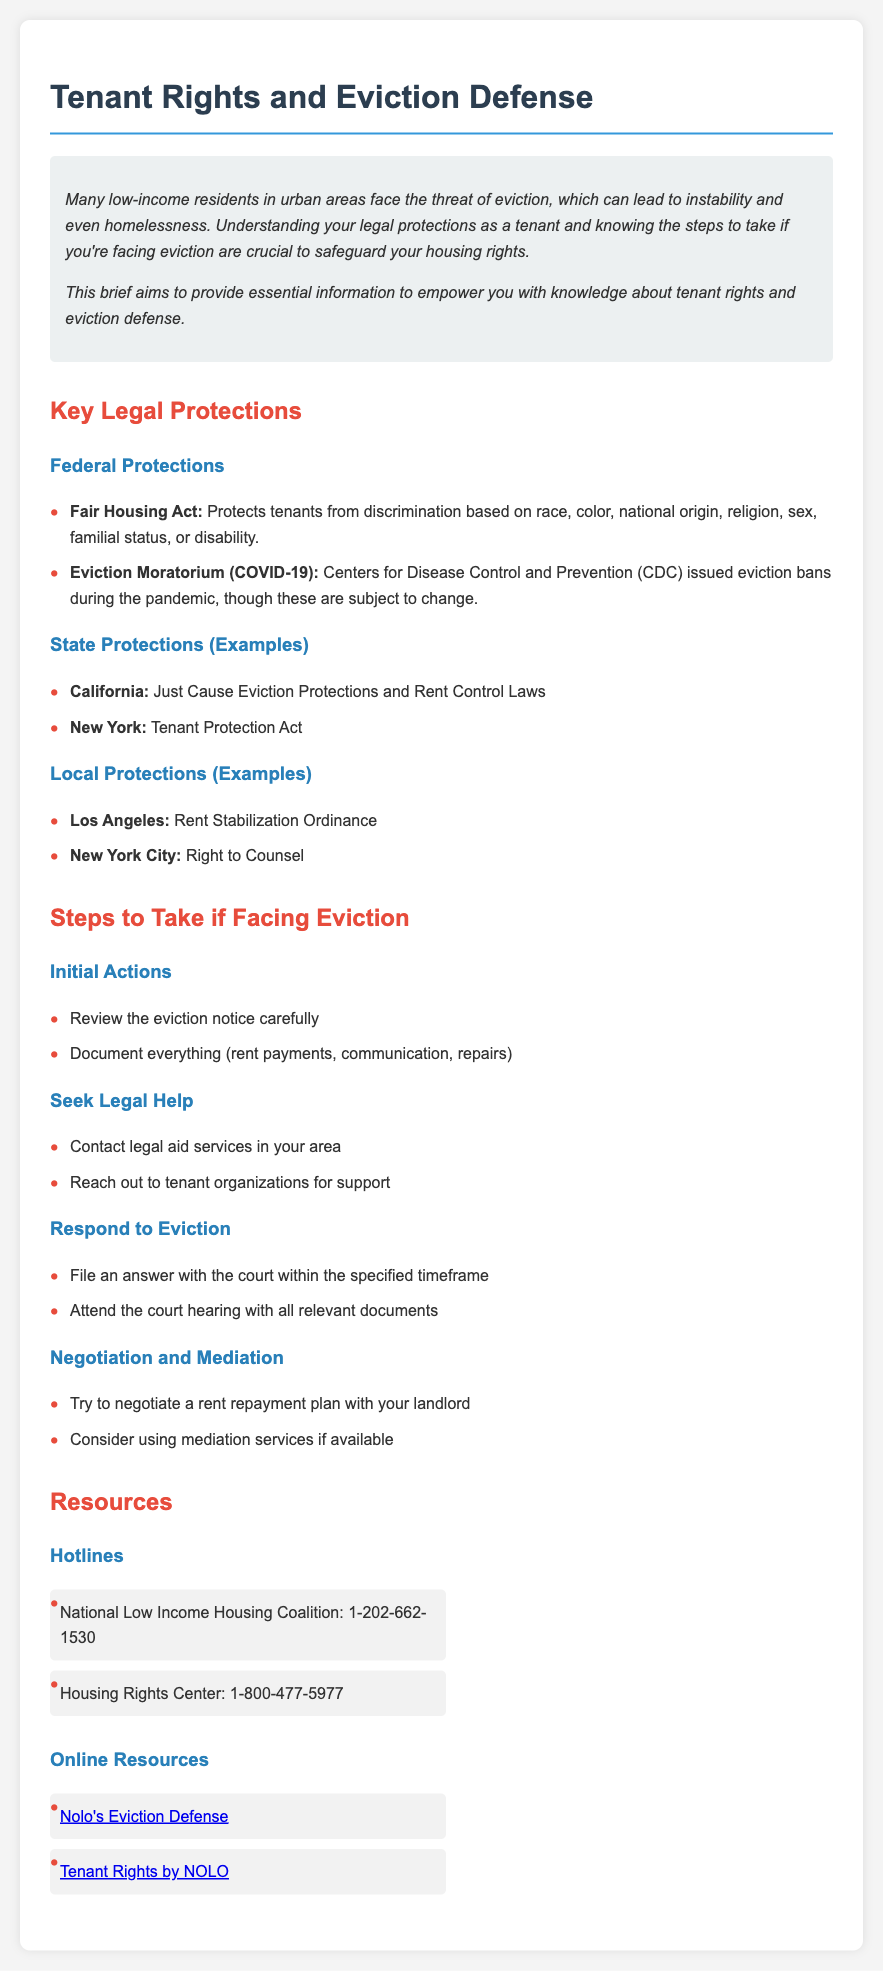what is the title of the document? The title of the document is stated in the <title> tag within the HTML, which outlines the subject of tenant rights and eviction defense.
Answer: Tenant Rights and Eviction Defense who issued the eviction moratorium during the pandemic? The document mentions the CDC, which is the Center for Disease Control and Prevention, as the issuer of the eviction moratorium.
Answer: CDC what should you document if facing eviction? The document lists various forms of documentation that should be kept, focusing on important aspects necessary for legal preparation.
Answer: everything (rent payments, communication, repairs) what are the initial actions to take when faced with eviction? The document specifies two preliminary steps to undertake upon receiving an eviction notice, emphasizing the importance of careful review and documentation.
Answer: Review the eviction notice carefully, Document everything which organization provides a hotline for low-income housing? The document cites a specific national organization that addresses housing issues for low-income residents and offers a help hotline.
Answer: National Low Income Housing Coalition what is one suggested negotiation tactic in the document? The document lists a strategy related to financial discussions, aimed at improving one’s standing during eviction disputes through direct communication with the landlord.
Answer: negotiate a rent repayment plan name one local protection example mentioned. The document provides examples of local tenant protections, highlighting specific regulations in different urban areas for tenant security.
Answer: Rent Stabilization Ordinance what should you do if you receive an eviction notice? The document indicates a specific first action that tenants should take to protect their rights upon receiving an eviction notice, signaling its legal importance.
Answer: Review the eviction notice carefully 